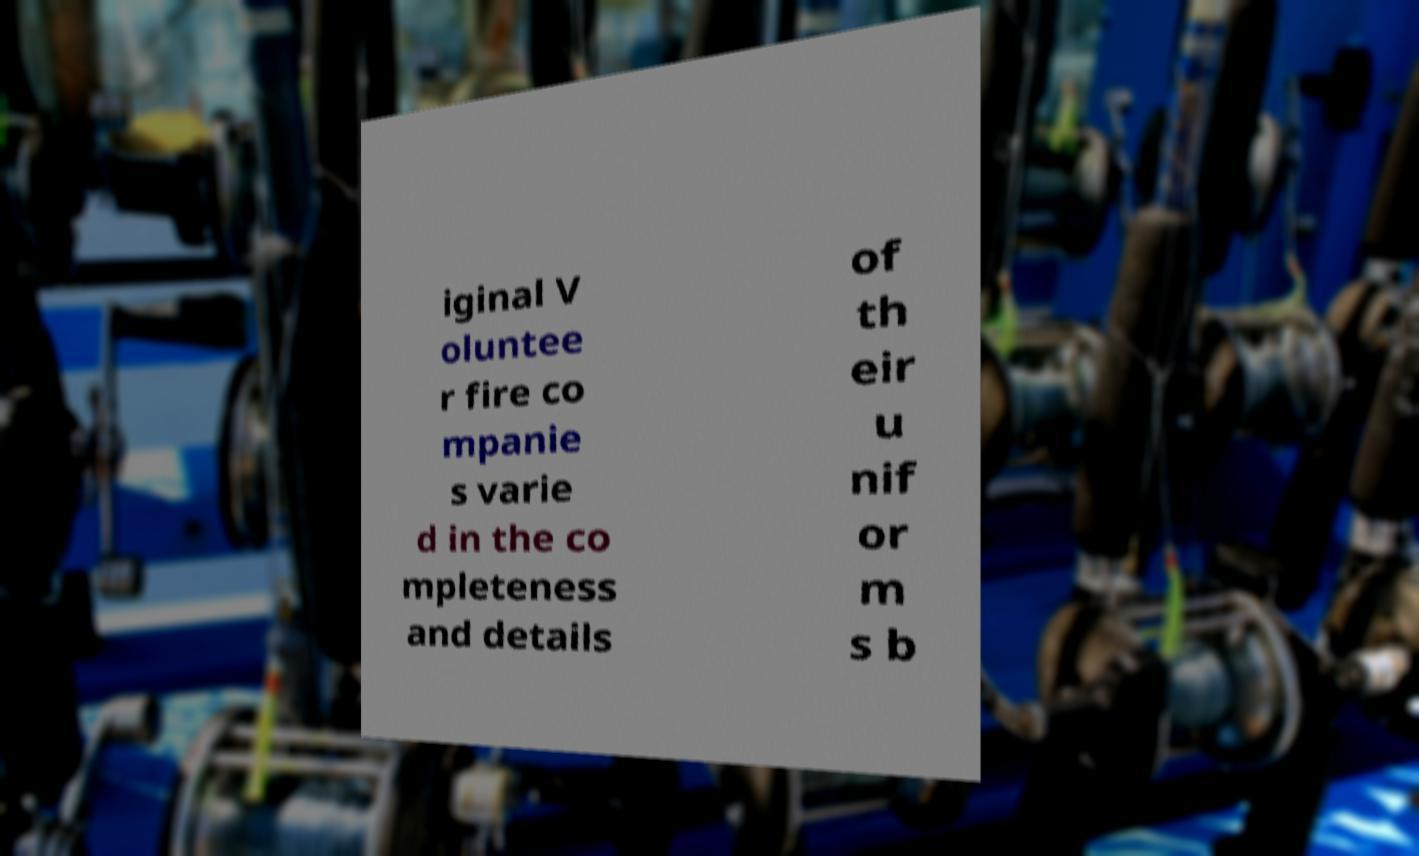Can you read and provide the text displayed in the image?This photo seems to have some interesting text. Can you extract and type it out for me? iginal V oluntee r fire co mpanie s varie d in the co mpleteness and details of th eir u nif or m s b 